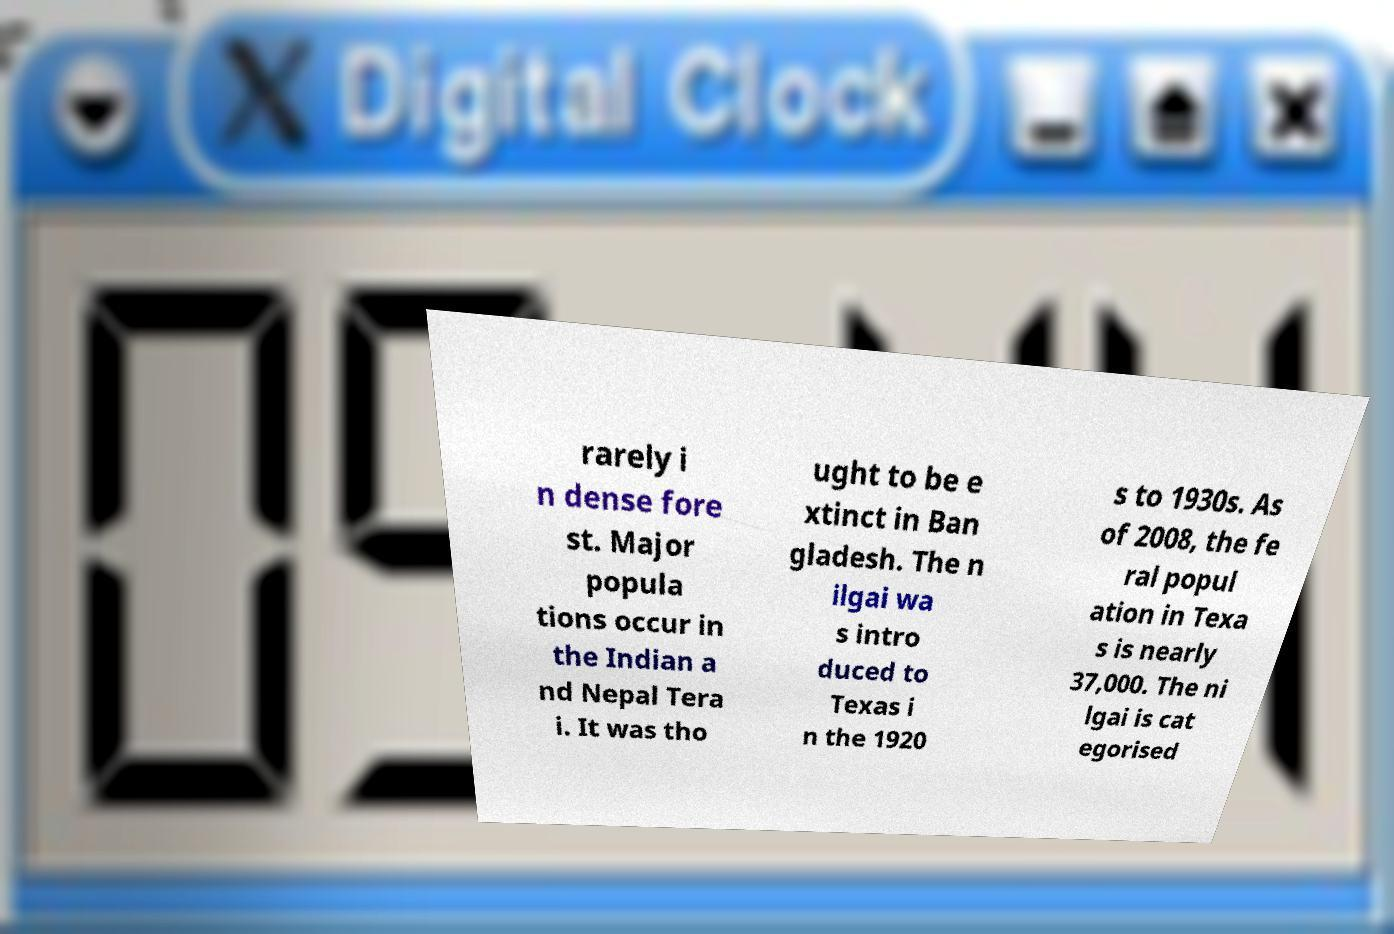Please identify and transcribe the text found in this image. rarely i n dense fore st. Major popula tions occur in the Indian a nd Nepal Tera i. It was tho ught to be e xtinct in Ban gladesh. The n ilgai wa s intro duced to Texas i n the 1920 s to 1930s. As of 2008, the fe ral popul ation in Texa s is nearly 37,000. The ni lgai is cat egorised 